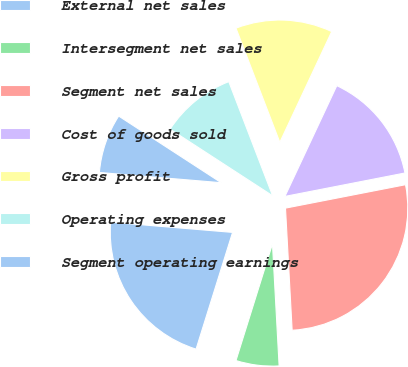Convert chart to OTSL. <chart><loc_0><loc_0><loc_500><loc_500><pie_chart><fcel>External net sales<fcel>Intersegment net sales<fcel>Segment net sales<fcel>Cost of goods sold<fcel>Gross profit<fcel>Operating expenses<fcel>Segment operating earnings<nl><fcel>21.51%<fcel>5.69%<fcel>27.2%<fcel>14.96%<fcel>12.81%<fcel>9.99%<fcel>7.84%<nl></chart> 